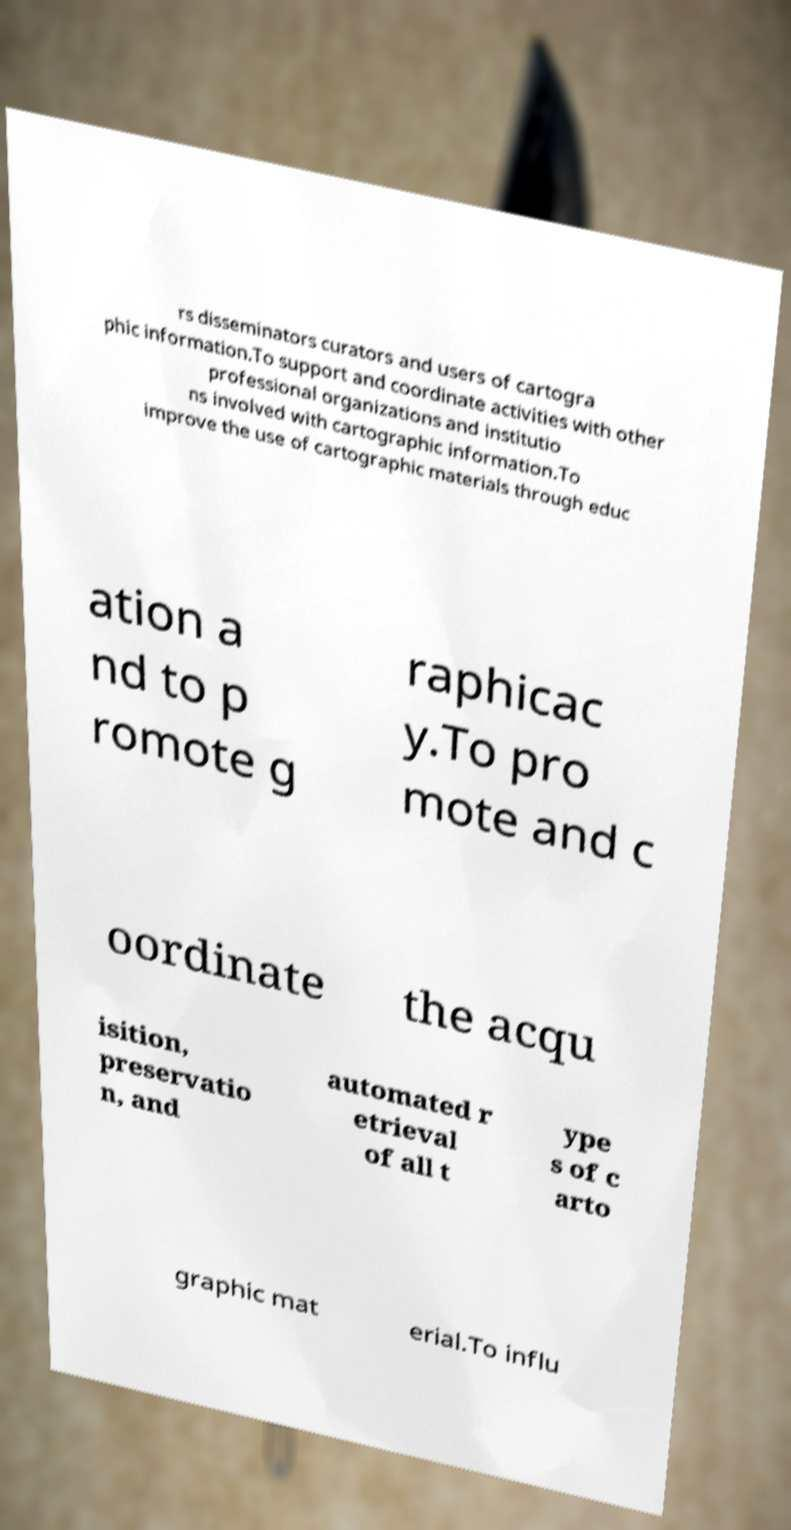For documentation purposes, I need the text within this image transcribed. Could you provide that? rs disseminators curators and users of cartogra phic information.To support and coordinate activities with other professional organizations and institutio ns involved with cartographic information.To improve the use of cartographic materials through educ ation a nd to p romote g raphicac y.To pro mote and c oordinate the acqu isition, preservatio n, and automated r etrieval of all t ype s of c arto graphic mat erial.To influ 